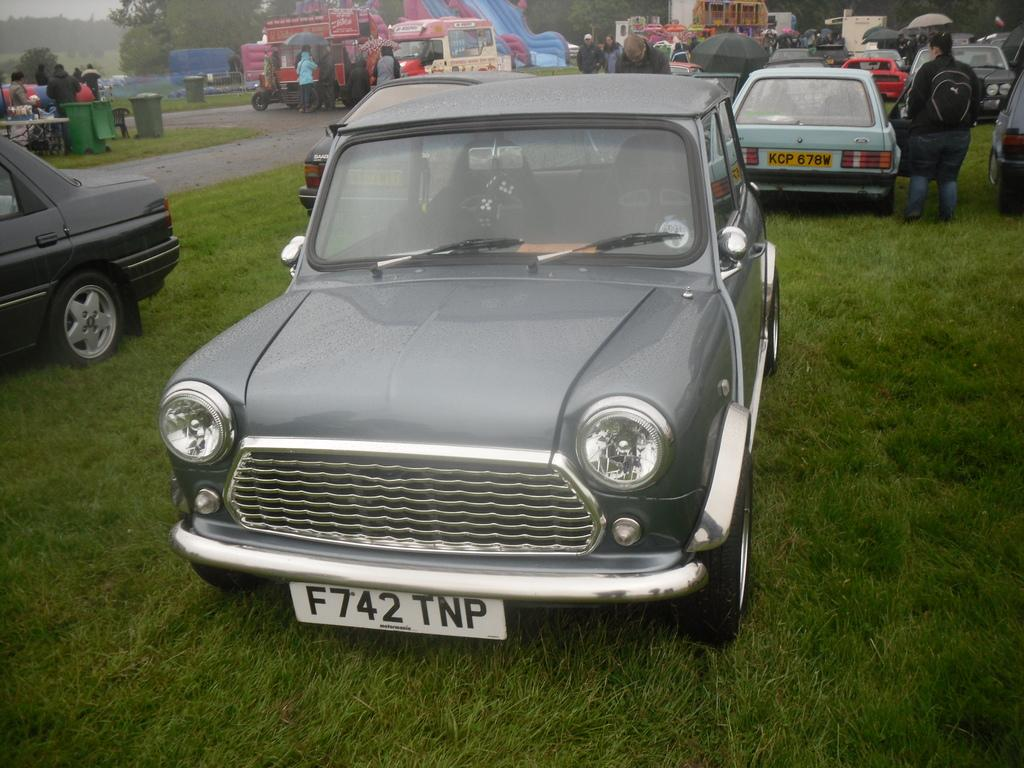What can be seen on the ground in the image? There are cars parked on the ground in the image. What type of pathway is visible in the image? There is a road visible in the image. What are the people in the image doing? There are people standing on the ground in the image. What can be seen in the distance in the image? There are trees in the background of the image, and the sky is visible in the background as well. Where is the throne located in the image? There is no throne present in the image. What is the tendency of the alarm in the image? There is no alarm present in the image, so it is not possible to determine its tendency. 